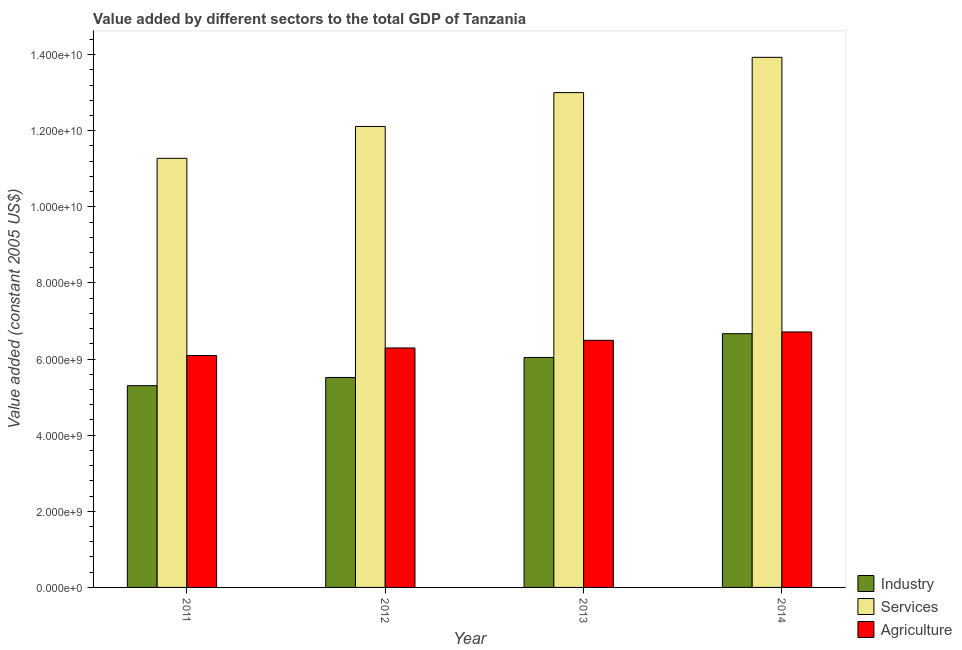How many bars are there on the 2nd tick from the right?
Provide a short and direct response. 3. What is the value added by agricultural sector in 2011?
Your response must be concise. 6.09e+09. Across all years, what is the maximum value added by industrial sector?
Keep it short and to the point. 6.67e+09. Across all years, what is the minimum value added by industrial sector?
Give a very brief answer. 5.30e+09. In which year was the value added by agricultural sector maximum?
Keep it short and to the point. 2014. In which year was the value added by industrial sector minimum?
Ensure brevity in your answer.  2011. What is the total value added by industrial sector in the graph?
Provide a short and direct response. 2.35e+1. What is the difference between the value added by services in 2013 and that in 2014?
Your answer should be compact. -9.26e+08. What is the difference between the value added by industrial sector in 2011 and the value added by agricultural sector in 2013?
Your response must be concise. -7.40e+08. What is the average value added by industrial sector per year?
Give a very brief answer. 5.88e+09. In how many years, is the value added by industrial sector greater than 9200000000 US$?
Offer a terse response. 0. What is the ratio of the value added by services in 2011 to that in 2014?
Give a very brief answer. 0.81. Is the difference between the value added by industrial sector in 2012 and 2013 greater than the difference between the value added by services in 2012 and 2013?
Ensure brevity in your answer.  No. What is the difference between the highest and the second highest value added by industrial sector?
Your response must be concise. 6.25e+08. What is the difference between the highest and the lowest value added by industrial sector?
Offer a very short reply. 1.37e+09. In how many years, is the value added by services greater than the average value added by services taken over all years?
Make the answer very short. 2. Is the sum of the value added by industrial sector in 2012 and 2014 greater than the maximum value added by agricultural sector across all years?
Provide a short and direct response. Yes. What does the 2nd bar from the left in 2014 represents?
Your answer should be very brief. Services. What does the 1st bar from the right in 2011 represents?
Keep it short and to the point. Agriculture. Is it the case that in every year, the sum of the value added by industrial sector and value added by services is greater than the value added by agricultural sector?
Ensure brevity in your answer.  Yes. How many bars are there?
Your answer should be compact. 12. Are all the bars in the graph horizontal?
Provide a short and direct response. No. How many years are there in the graph?
Make the answer very short. 4. Does the graph contain any zero values?
Your response must be concise. No. Does the graph contain grids?
Offer a very short reply. No. Where does the legend appear in the graph?
Make the answer very short. Bottom right. How many legend labels are there?
Your response must be concise. 3. What is the title of the graph?
Ensure brevity in your answer.  Value added by different sectors to the total GDP of Tanzania. What is the label or title of the Y-axis?
Ensure brevity in your answer.  Value added (constant 2005 US$). What is the Value added (constant 2005 US$) of Industry in 2011?
Offer a very short reply. 5.30e+09. What is the Value added (constant 2005 US$) of Services in 2011?
Offer a terse response. 1.13e+1. What is the Value added (constant 2005 US$) in Agriculture in 2011?
Ensure brevity in your answer.  6.09e+09. What is the Value added (constant 2005 US$) of Industry in 2012?
Your answer should be very brief. 5.52e+09. What is the Value added (constant 2005 US$) of Services in 2012?
Provide a short and direct response. 1.21e+1. What is the Value added (constant 2005 US$) of Agriculture in 2012?
Your answer should be compact. 6.29e+09. What is the Value added (constant 2005 US$) in Industry in 2013?
Your response must be concise. 6.04e+09. What is the Value added (constant 2005 US$) of Services in 2013?
Your answer should be very brief. 1.30e+1. What is the Value added (constant 2005 US$) in Agriculture in 2013?
Offer a very short reply. 6.49e+09. What is the Value added (constant 2005 US$) in Industry in 2014?
Offer a very short reply. 6.67e+09. What is the Value added (constant 2005 US$) in Services in 2014?
Your answer should be very brief. 1.39e+1. What is the Value added (constant 2005 US$) in Agriculture in 2014?
Your answer should be compact. 6.71e+09. Across all years, what is the maximum Value added (constant 2005 US$) of Industry?
Give a very brief answer. 6.67e+09. Across all years, what is the maximum Value added (constant 2005 US$) in Services?
Your response must be concise. 1.39e+1. Across all years, what is the maximum Value added (constant 2005 US$) in Agriculture?
Offer a very short reply. 6.71e+09. Across all years, what is the minimum Value added (constant 2005 US$) of Industry?
Make the answer very short. 5.30e+09. Across all years, what is the minimum Value added (constant 2005 US$) of Services?
Give a very brief answer. 1.13e+1. Across all years, what is the minimum Value added (constant 2005 US$) of Agriculture?
Make the answer very short. 6.09e+09. What is the total Value added (constant 2005 US$) in Industry in the graph?
Give a very brief answer. 2.35e+1. What is the total Value added (constant 2005 US$) in Services in the graph?
Your response must be concise. 5.03e+1. What is the total Value added (constant 2005 US$) in Agriculture in the graph?
Offer a very short reply. 2.56e+1. What is the difference between the Value added (constant 2005 US$) in Industry in 2011 and that in 2012?
Your answer should be very brief. -2.15e+08. What is the difference between the Value added (constant 2005 US$) in Services in 2011 and that in 2012?
Ensure brevity in your answer.  -8.38e+08. What is the difference between the Value added (constant 2005 US$) of Agriculture in 2011 and that in 2012?
Offer a very short reply. -1.98e+08. What is the difference between the Value added (constant 2005 US$) of Industry in 2011 and that in 2013?
Your response must be concise. -7.40e+08. What is the difference between the Value added (constant 2005 US$) of Services in 2011 and that in 2013?
Give a very brief answer. -1.73e+09. What is the difference between the Value added (constant 2005 US$) of Agriculture in 2011 and that in 2013?
Provide a succinct answer. -3.99e+08. What is the difference between the Value added (constant 2005 US$) of Industry in 2011 and that in 2014?
Provide a short and direct response. -1.37e+09. What is the difference between the Value added (constant 2005 US$) of Services in 2011 and that in 2014?
Make the answer very short. -2.65e+09. What is the difference between the Value added (constant 2005 US$) in Agriculture in 2011 and that in 2014?
Make the answer very short. -6.19e+08. What is the difference between the Value added (constant 2005 US$) of Industry in 2012 and that in 2013?
Offer a very short reply. -5.26e+08. What is the difference between the Value added (constant 2005 US$) of Services in 2012 and that in 2013?
Keep it short and to the point. -8.90e+08. What is the difference between the Value added (constant 2005 US$) in Agriculture in 2012 and that in 2013?
Keep it short and to the point. -2.01e+08. What is the difference between the Value added (constant 2005 US$) in Industry in 2012 and that in 2014?
Your answer should be very brief. -1.15e+09. What is the difference between the Value added (constant 2005 US$) in Services in 2012 and that in 2014?
Provide a succinct answer. -1.82e+09. What is the difference between the Value added (constant 2005 US$) of Agriculture in 2012 and that in 2014?
Provide a short and direct response. -4.21e+08. What is the difference between the Value added (constant 2005 US$) of Industry in 2013 and that in 2014?
Keep it short and to the point. -6.25e+08. What is the difference between the Value added (constant 2005 US$) in Services in 2013 and that in 2014?
Your answer should be compact. -9.26e+08. What is the difference between the Value added (constant 2005 US$) of Agriculture in 2013 and that in 2014?
Provide a short and direct response. -2.20e+08. What is the difference between the Value added (constant 2005 US$) of Industry in 2011 and the Value added (constant 2005 US$) of Services in 2012?
Keep it short and to the point. -6.81e+09. What is the difference between the Value added (constant 2005 US$) of Industry in 2011 and the Value added (constant 2005 US$) of Agriculture in 2012?
Offer a terse response. -9.90e+08. What is the difference between the Value added (constant 2005 US$) in Services in 2011 and the Value added (constant 2005 US$) in Agriculture in 2012?
Offer a very short reply. 4.98e+09. What is the difference between the Value added (constant 2005 US$) of Industry in 2011 and the Value added (constant 2005 US$) of Services in 2013?
Provide a succinct answer. -7.70e+09. What is the difference between the Value added (constant 2005 US$) in Industry in 2011 and the Value added (constant 2005 US$) in Agriculture in 2013?
Your answer should be very brief. -1.19e+09. What is the difference between the Value added (constant 2005 US$) of Services in 2011 and the Value added (constant 2005 US$) of Agriculture in 2013?
Your answer should be very brief. 4.78e+09. What is the difference between the Value added (constant 2005 US$) of Industry in 2011 and the Value added (constant 2005 US$) of Services in 2014?
Offer a very short reply. -8.63e+09. What is the difference between the Value added (constant 2005 US$) in Industry in 2011 and the Value added (constant 2005 US$) in Agriculture in 2014?
Your response must be concise. -1.41e+09. What is the difference between the Value added (constant 2005 US$) in Services in 2011 and the Value added (constant 2005 US$) in Agriculture in 2014?
Offer a terse response. 4.56e+09. What is the difference between the Value added (constant 2005 US$) in Industry in 2012 and the Value added (constant 2005 US$) in Services in 2013?
Provide a succinct answer. -7.49e+09. What is the difference between the Value added (constant 2005 US$) of Industry in 2012 and the Value added (constant 2005 US$) of Agriculture in 2013?
Provide a succinct answer. -9.77e+08. What is the difference between the Value added (constant 2005 US$) of Services in 2012 and the Value added (constant 2005 US$) of Agriculture in 2013?
Your response must be concise. 5.62e+09. What is the difference between the Value added (constant 2005 US$) of Industry in 2012 and the Value added (constant 2005 US$) of Services in 2014?
Your answer should be compact. -8.41e+09. What is the difference between the Value added (constant 2005 US$) in Industry in 2012 and the Value added (constant 2005 US$) in Agriculture in 2014?
Offer a terse response. -1.20e+09. What is the difference between the Value added (constant 2005 US$) of Services in 2012 and the Value added (constant 2005 US$) of Agriculture in 2014?
Ensure brevity in your answer.  5.40e+09. What is the difference between the Value added (constant 2005 US$) of Industry in 2013 and the Value added (constant 2005 US$) of Services in 2014?
Give a very brief answer. -7.89e+09. What is the difference between the Value added (constant 2005 US$) in Industry in 2013 and the Value added (constant 2005 US$) in Agriculture in 2014?
Give a very brief answer. -6.71e+08. What is the difference between the Value added (constant 2005 US$) of Services in 2013 and the Value added (constant 2005 US$) of Agriculture in 2014?
Your answer should be very brief. 6.29e+09. What is the average Value added (constant 2005 US$) of Industry per year?
Offer a very short reply. 5.88e+09. What is the average Value added (constant 2005 US$) of Services per year?
Offer a very short reply. 1.26e+1. What is the average Value added (constant 2005 US$) in Agriculture per year?
Offer a very short reply. 6.40e+09. In the year 2011, what is the difference between the Value added (constant 2005 US$) of Industry and Value added (constant 2005 US$) of Services?
Give a very brief answer. -5.97e+09. In the year 2011, what is the difference between the Value added (constant 2005 US$) of Industry and Value added (constant 2005 US$) of Agriculture?
Keep it short and to the point. -7.92e+08. In the year 2011, what is the difference between the Value added (constant 2005 US$) of Services and Value added (constant 2005 US$) of Agriculture?
Offer a terse response. 5.18e+09. In the year 2012, what is the difference between the Value added (constant 2005 US$) of Industry and Value added (constant 2005 US$) of Services?
Offer a terse response. -6.59e+09. In the year 2012, what is the difference between the Value added (constant 2005 US$) of Industry and Value added (constant 2005 US$) of Agriculture?
Offer a very short reply. -7.76e+08. In the year 2012, what is the difference between the Value added (constant 2005 US$) in Services and Value added (constant 2005 US$) in Agriculture?
Keep it short and to the point. 5.82e+09. In the year 2013, what is the difference between the Value added (constant 2005 US$) of Industry and Value added (constant 2005 US$) of Services?
Keep it short and to the point. -6.96e+09. In the year 2013, what is the difference between the Value added (constant 2005 US$) in Industry and Value added (constant 2005 US$) in Agriculture?
Keep it short and to the point. -4.51e+08. In the year 2013, what is the difference between the Value added (constant 2005 US$) of Services and Value added (constant 2005 US$) of Agriculture?
Give a very brief answer. 6.51e+09. In the year 2014, what is the difference between the Value added (constant 2005 US$) of Industry and Value added (constant 2005 US$) of Services?
Your response must be concise. -7.26e+09. In the year 2014, what is the difference between the Value added (constant 2005 US$) in Industry and Value added (constant 2005 US$) in Agriculture?
Offer a terse response. -4.57e+07. In the year 2014, what is the difference between the Value added (constant 2005 US$) of Services and Value added (constant 2005 US$) of Agriculture?
Make the answer very short. 7.21e+09. What is the ratio of the Value added (constant 2005 US$) of Industry in 2011 to that in 2012?
Give a very brief answer. 0.96. What is the ratio of the Value added (constant 2005 US$) in Services in 2011 to that in 2012?
Offer a terse response. 0.93. What is the ratio of the Value added (constant 2005 US$) of Agriculture in 2011 to that in 2012?
Your answer should be very brief. 0.97. What is the ratio of the Value added (constant 2005 US$) in Industry in 2011 to that in 2013?
Keep it short and to the point. 0.88. What is the ratio of the Value added (constant 2005 US$) of Services in 2011 to that in 2013?
Your answer should be very brief. 0.87. What is the ratio of the Value added (constant 2005 US$) of Agriculture in 2011 to that in 2013?
Offer a terse response. 0.94. What is the ratio of the Value added (constant 2005 US$) in Industry in 2011 to that in 2014?
Offer a terse response. 0.8. What is the ratio of the Value added (constant 2005 US$) in Services in 2011 to that in 2014?
Provide a short and direct response. 0.81. What is the ratio of the Value added (constant 2005 US$) of Agriculture in 2011 to that in 2014?
Make the answer very short. 0.91. What is the ratio of the Value added (constant 2005 US$) of Services in 2012 to that in 2013?
Ensure brevity in your answer.  0.93. What is the ratio of the Value added (constant 2005 US$) of Agriculture in 2012 to that in 2013?
Ensure brevity in your answer.  0.97. What is the ratio of the Value added (constant 2005 US$) in Industry in 2012 to that in 2014?
Your response must be concise. 0.83. What is the ratio of the Value added (constant 2005 US$) of Services in 2012 to that in 2014?
Offer a very short reply. 0.87. What is the ratio of the Value added (constant 2005 US$) in Agriculture in 2012 to that in 2014?
Provide a succinct answer. 0.94. What is the ratio of the Value added (constant 2005 US$) in Industry in 2013 to that in 2014?
Keep it short and to the point. 0.91. What is the ratio of the Value added (constant 2005 US$) of Services in 2013 to that in 2014?
Offer a very short reply. 0.93. What is the ratio of the Value added (constant 2005 US$) in Agriculture in 2013 to that in 2014?
Keep it short and to the point. 0.97. What is the difference between the highest and the second highest Value added (constant 2005 US$) of Industry?
Provide a succinct answer. 6.25e+08. What is the difference between the highest and the second highest Value added (constant 2005 US$) in Services?
Give a very brief answer. 9.26e+08. What is the difference between the highest and the second highest Value added (constant 2005 US$) in Agriculture?
Your response must be concise. 2.20e+08. What is the difference between the highest and the lowest Value added (constant 2005 US$) of Industry?
Your answer should be compact. 1.37e+09. What is the difference between the highest and the lowest Value added (constant 2005 US$) in Services?
Make the answer very short. 2.65e+09. What is the difference between the highest and the lowest Value added (constant 2005 US$) of Agriculture?
Provide a succinct answer. 6.19e+08. 